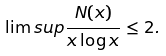Convert formula to latex. <formula><loc_0><loc_0><loc_500><loc_500>\lim s u p \frac { N ( x ) } { x \log x } \leq 2 .</formula> 